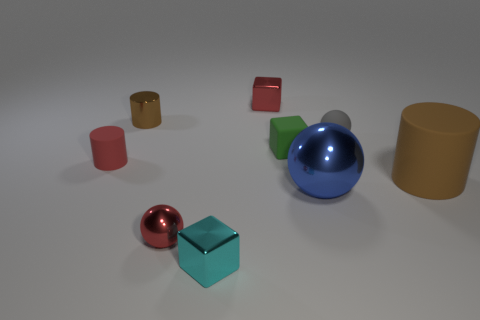Are there an equal number of brown metal objects that are on the right side of the small matte cube and tiny metal cylinders that are in front of the small matte ball?
Your response must be concise. Yes. How many red objects are tiny cylinders or metal spheres?
Provide a succinct answer. 2. Do the large matte cylinder and the sphere that is on the left side of the big sphere have the same color?
Your answer should be very brief. No. How many other things are there of the same color as the shiny cylinder?
Ensure brevity in your answer.  1. Are there fewer rubber cylinders than brown metal things?
Offer a terse response. No. There is a small block that is behind the gray object that is in front of the tiny metallic cylinder; how many large shiny balls are behind it?
Give a very brief answer. 0. What is the size of the brown object that is to the left of the green rubber thing?
Your answer should be very brief. Small. There is a red thing that is behind the small gray sphere; is it the same shape as the tiny red matte object?
Make the answer very short. No. There is a red thing that is the same shape as the small green matte object; what is it made of?
Provide a succinct answer. Metal. Are there any other things that have the same size as the red sphere?
Your answer should be very brief. Yes. 